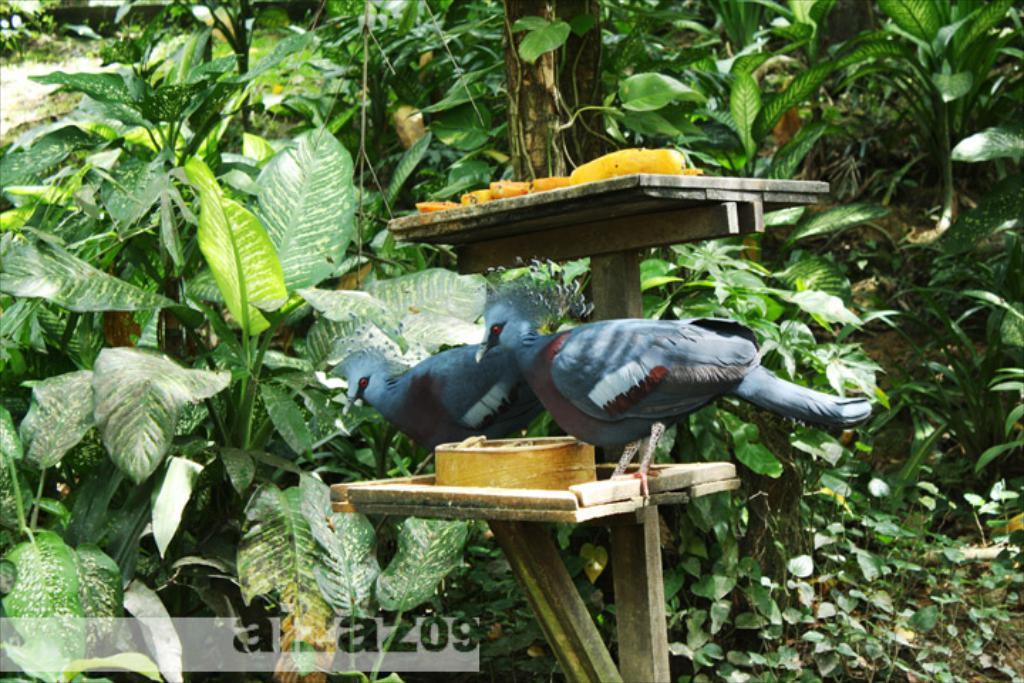What is on the wooden stand in the image? There are birds on the wooden stand. What can be seen behind the wooden stand? Trees and plants are visible behind the wooden stand. What is the color of the object on the wooden stand? The object on the wooden stand is yellow. How does the fear of heights affect the birds on the wooden stand? There is no indication of fear or heights in the image, as it features birds on a wooden stand with trees and plants in the background. 